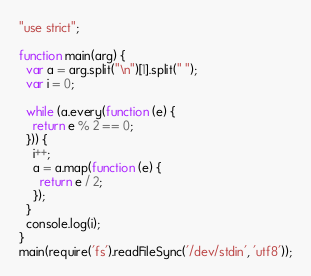<code> <loc_0><loc_0><loc_500><loc_500><_JavaScript_>"use strict";

function main(arg) {
  var a = arg.split("\n")[1].split(" ");
  var i = 0;

  while (a.every(function (e) {
    return e % 2 == 0;
  })) {
    i++;
    a = a.map(function (e) {
      return e / 2;
    });
  }
  console.log(i);
}
main(require('fs').readFileSync('/dev/stdin', 'utf8'));</code> 